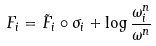Convert formula to latex. <formula><loc_0><loc_0><loc_500><loc_500>F _ { i } = \tilde { F } _ { i } \circ \sigma _ { i } + \log \frac { \omega _ { i } ^ { n } } { \omega ^ { n } }</formula> 